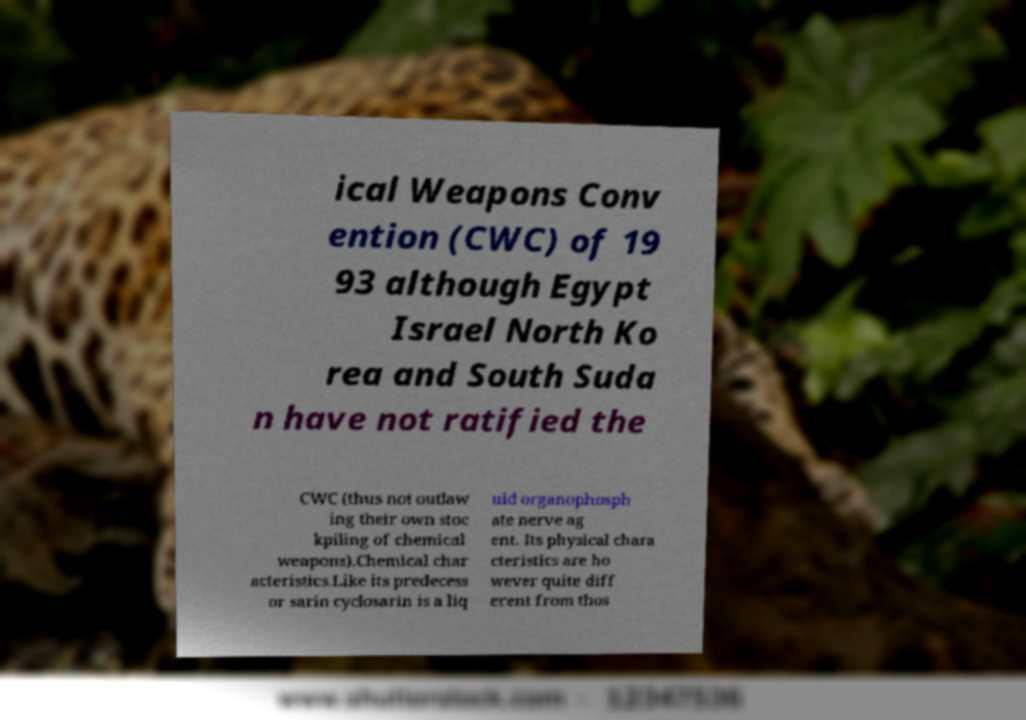For documentation purposes, I need the text within this image transcribed. Could you provide that? ical Weapons Conv ention (CWC) of 19 93 although Egypt Israel North Ko rea and South Suda n have not ratified the CWC (thus not outlaw ing their own stoc kpiling of chemical weapons).Chemical char acteristics.Like its predecess or sarin cyclosarin is a liq uid organophosph ate nerve ag ent. Its physical chara cteristics are ho wever quite diff erent from thos 